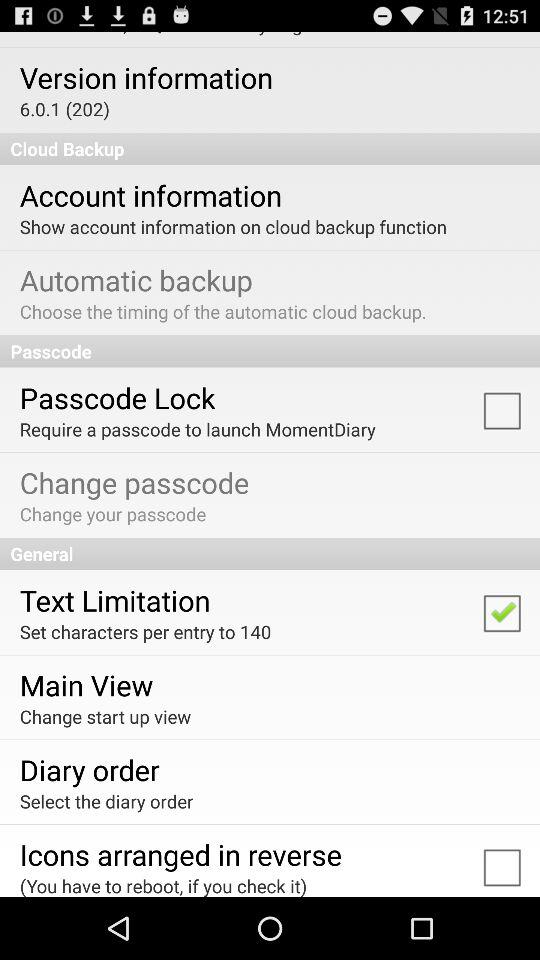Which version of the application is this? The version is 6.0.1 (202). 